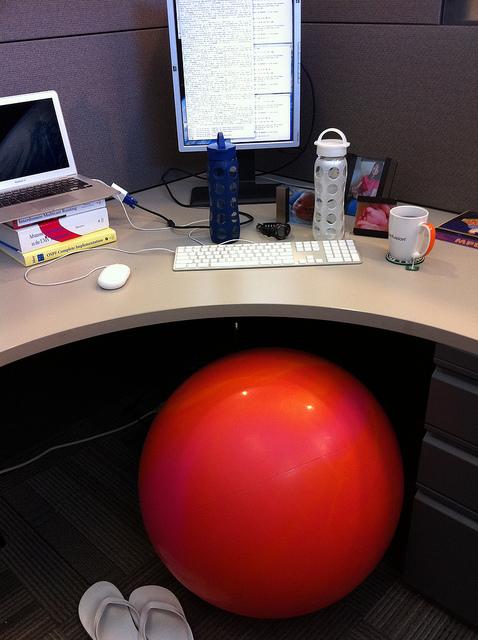How many water bottles are there?
Keep it brief. 2. Can you sit on this ball?
Give a very brief answer. Yes. What kind of shoes are on the ground?
Answer briefly. Flip flops. 